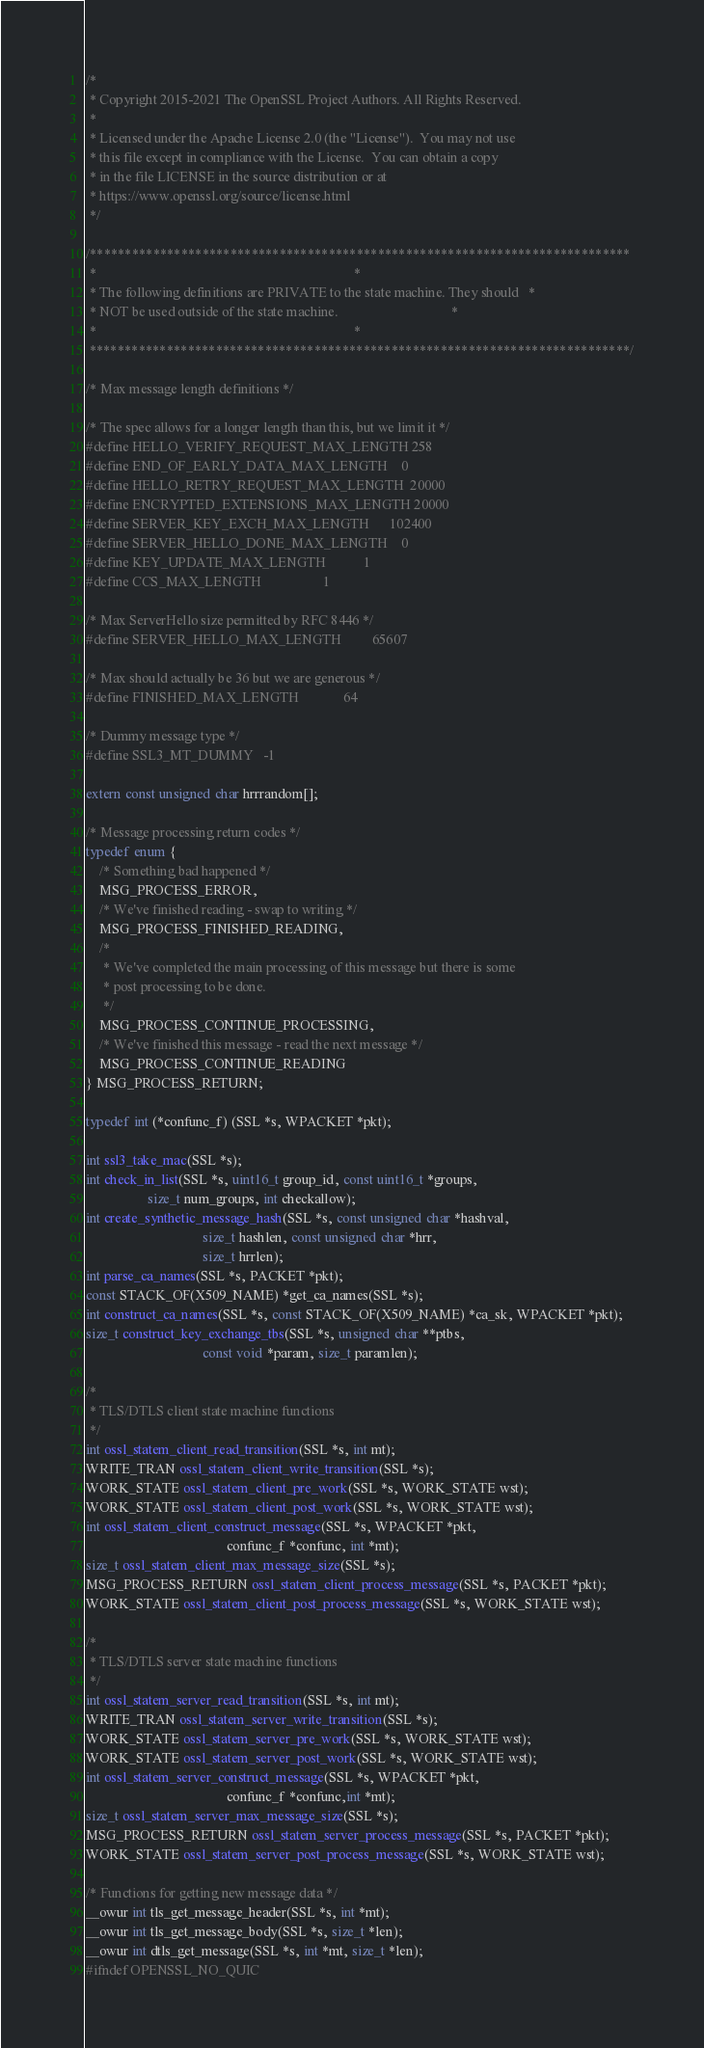<code> <loc_0><loc_0><loc_500><loc_500><_C_>/*
 * Copyright 2015-2021 The OpenSSL Project Authors. All Rights Reserved.
 *
 * Licensed under the Apache License 2.0 (the "License").  You may not use
 * this file except in compliance with the License.  You can obtain a copy
 * in the file LICENSE in the source distribution or at
 * https://www.openssl.org/source/license.html
 */

/*****************************************************************************
 *                                                                           *
 * The following definitions are PRIVATE to the state machine. They should   *
 * NOT be used outside of the state machine.                                 *
 *                                                                           *
 *****************************************************************************/

/* Max message length definitions */

/* The spec allows for a longer length than this, but we limit it */
#define HELLO_VERIFY_REQUEST_MAX_LENGTH 258
#define END_OF_EARLY_DATA_MAX_LENGTH    0
#define HELLO_RETRY_REQUEST_MAX_LENGTH  20000
#define ENCRYPTED_EXTENSIONS_MAX_LENGTH 20000
#define SERVER_KEY_EXCH_MAX_LENGTH      102400
#define SERVER_HELLO_DONE_MAX_LENGTH    0
#define KEY_UPDATE_MAX_LENGTH           1
#define CCS_MAX_LENGTH                  1

/* Max ServerHello size permitted by RFC 8446 */
#define SERVER_HELLO_MAX_LENGTH         65607

/* Max should actually be 36 but we are generous */
#define FINISHED_MAX_LENGTH             64

/* Dummy message type */
#define SSL3_MT_DUMMY   -1

extern const unsigned char hrrrandom[];

/* Message processing return codes */
typedef enum {
    /* Something bad happened */
    MSG_PROCESS_ERROR,
    /* We've finished reading - swap to writing */
    MSG_PROCESS_FINISHED_READING,
    /*
     * We've completed the main processing of this message but there is some
     * post processing to be done.
     */
    MSG_PROCESS_CONTINUE_PROCESSING,
    /* We've finished this message - read the next message */
    MSG_PROCESS_CONTINUE_READING
} MSG_PROCESS_RETURN;

typedef int (*confunc_f) (SSL *s, WPACKET *pkt);

int ssl3_take_mac(SSL *s);
int check_in_list(SSL *s, uint16_t group_id, const uint16_t *groups,
                  size_t num_groups, int checkallow);
int create_synthetic_message_hash(SSL *s, const unsigned char *hashval,
                                  size_t hashlen, const unsigned char *hrr,
                                  size_t hrrlen);
int parse_ca_names(SSL *s, PACKET *pkt);
const STACK_OF(X509_NAME) *get_ca_names(SSL *s);
int construct_ca_names(SSL *s, const STACK_OF(X509_NAME) *ca_sk, WPACKET *pkt);
size_t construct_key_exchange_tbs(SSL *s, unsigned char **ptbs,
                                  const void *param, size_t paramlen);

/*
 * TLS/DTLS client state machine functions
 */
int ossl_statem_client_read_transition(SSL *s, int mt);
WRITE_TRAN ossl_statem_client_write_transition(SSL *s);
WORK_STATE ossl_statem_client_pre_work(SSL *s, WORK_STATE wst);
WORK_STATE ossl_statem_client_post_work(SSL *s, WORK_STATE wst);
int ossl_statem_client_construct_message(SSL *s, WPACKET *pkt,
                                         confunc_f *confunc, int *mt);
size_t ossl_statem_client_max_message_size(SSL *s);
MSG_PROCESS_RETURN ossl_statem_client_process_message(SSL *s, PACKET *pkt);
WORK_STATE ossl_statem_client_post_process_message(SSL *s, WORK_STATE wst);

/*
 * TLS/DTLS server state machine functions
 */
int ossl_statem_server_read_transition(SSL *s, int mt);
WRITE_TRAN ossl_statem_server_write_transition(SSL *s);
WORK_STATE ossl_statem_server_pre_work(SSL *s, WORK_STATE wst);
WORK_STATE ossl_statem_server_post_work(SSL *s, WORK_STATE wst);
int ossl_statem_server_construct_message(SSL *s, WPACKET *pkt,
                                         confunc_f *confunc,int *mt);
size_t ossl_statem_server_max_message_size(SSL *s);
MSG_PROCESS_RETURN ossl_statem_server_process_message(SSL *s, PACKET *pkt);
WORK_STATE ossl_statem_server_post_process_message(SSL *s, WORK_STATE wst);

/* Functions for getting new message data */
__owur int tls_get_message_header(SSL *s, int *mt);
__owur int tls_get_message_body(SSL *s, size_t *len);
__owur int dtls_get_message(SSL *s, int *mt, size_t *len);
#ifndef OPENSSL_NO_QUIC</code> 